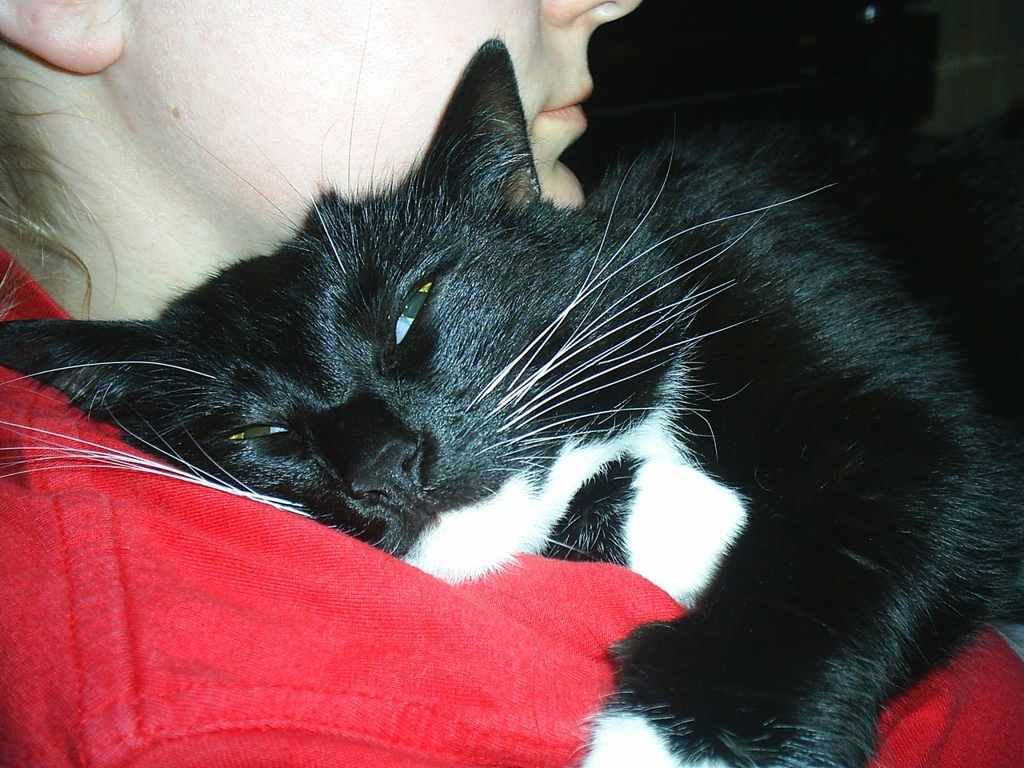What might the cat be feeling in this photo? Although we can't know for sure, the cat's relaxed posture and half-closed eyes suggest it may be feeling content and comfortable, perhaps enjoying the warmth and companionship of the person holding it. 